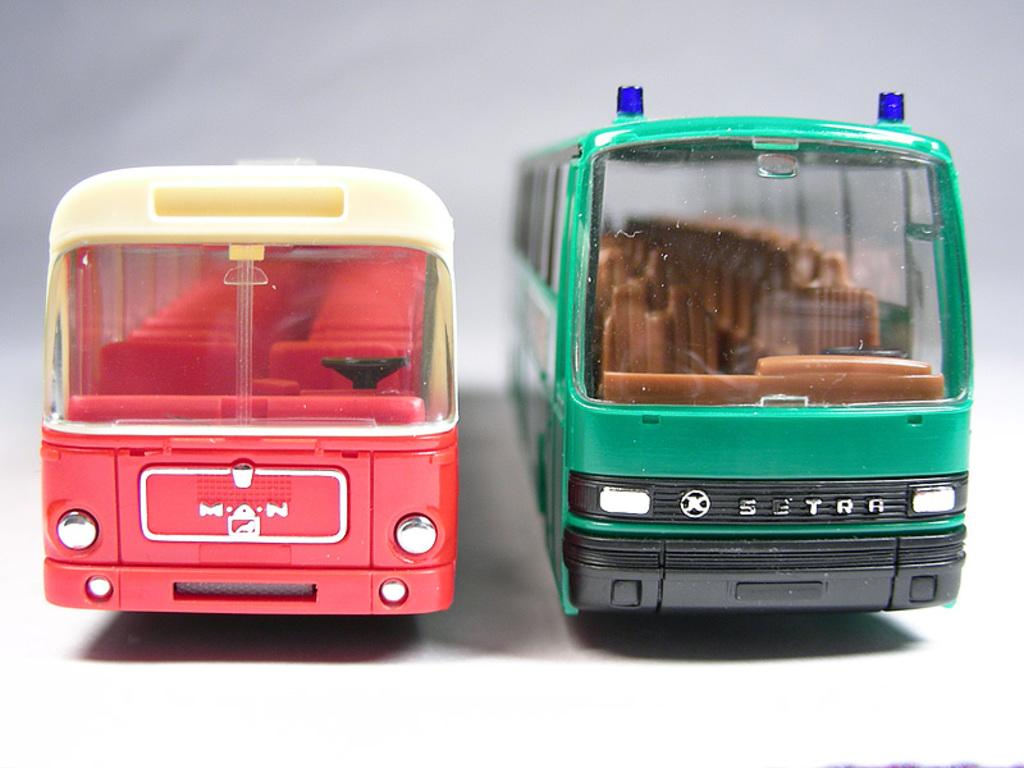What is the main subject in the center of the image? There are toy buses in the center of the image. What type of sugar is being used to sweeten the camp in the image? There is no camp or sugar present in the image; it features toy buses in the center. 